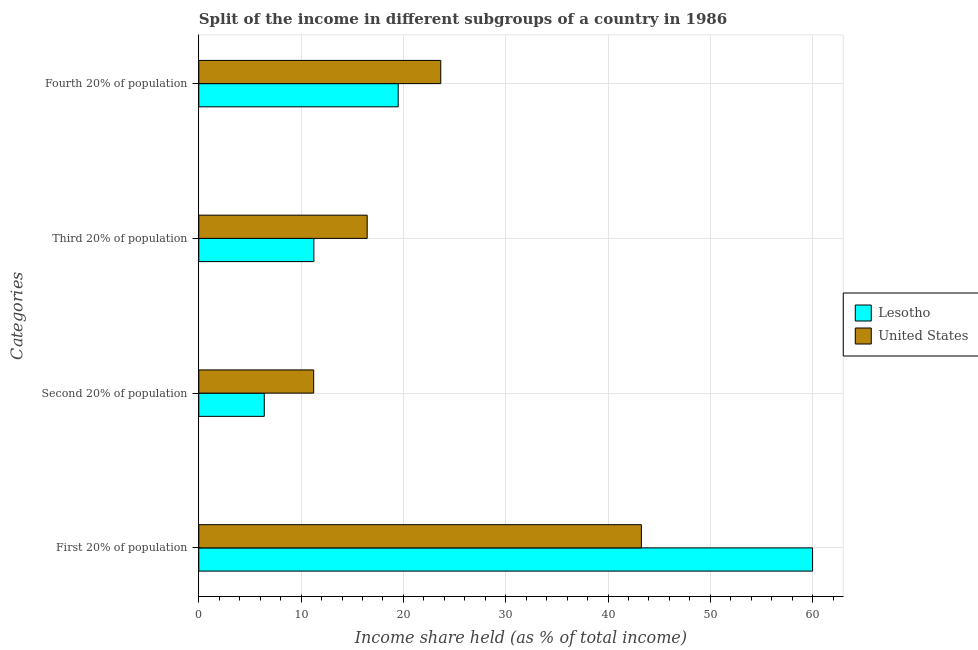How many different coloured bars are there?
Ensure brevity in your answer.  2. Are the number of bars per tick equal to the number of legend labels?
Ensure brevity in your answer.  Yes. Are the number of bars on each tick of the Y-axis equal?
Your response must be concise. Yes. How many bars are there on the 2nd tick from the bottom?
Your answer should be very brief. 2. What is the label of the 3rd group of bars from the top?
Make the answer very short. Second 20% of population. What is the share of the income held by first 20% of the population in Lesotho?
Keep it short and to the point. 59.99. Across all countries, what is the maximum share of the income held by fourth 20% of the population?
Provide a succinct answer. 23.65. Across all countries, what is the minimum share of the income held by first 20% of the population?
Provide a succinct answer. 43.26. In which country was the share of the income held by second 20% of the population maximum?
Give a very brief answer. United States. In which country was the share of the income held by second 20% of the population minimum?
Your response must be concise. Lesotho. What is the total share of the income held by second 20% of the population in the graph?
Offer a terse response. 17.63. What is the difference between the share of the income held by first 20% of the population in United States and that in Lesotho?
Keep it short and to the point. -16.73. What is the difference between the share of the income held by fourth 20% of the population in United States and the share of the income held by first 20% of the population in Lesotho?
Keep it short and to the point. -36.34. What is the average share of the income held by first 20% of the population per country?
Your answer should be compact. 51.62. What is the difference between the share of the income held by fourth 20% of the population and share of the income held by third 20% of the population in Lesotho?
Provide a short and direct response. 8.24. In how many countries, is the share of the income held by third 20% of the population greater than 2 %?
Offer a very short reply. 2. What is the ratio of the share of the income held by fourth 20% of the population in Lesotho to that in United States?
Your response must be concise. 0.82. Is the share of the income held by second 20% of the population in United States less than that in Lesotho?
Your response must be concise. No. Is the difference between the share of the income held by fourth 20% of the population in Lesotho and United States greater than the difference between the share of the income held by third 20% of the population in Lesotho and United States?
Give a very brief answer. Yes. What is the difference between the highest and the second highest share of the income held by fourth 20% of the population?
Keep it short and to the point. 4.16. What is the difference between the highest and the lowest share of the income held by second 20% of the population?
Ensure brevity in your answer.  4.83. In how many countries, is the share of the income held by second 20% of the population greater than the average share of the income held by second 20% of the population taken over all countries?
Provide a succinct answer. 1. Is it the case that in every country, the sum of the share of the income held by first 20% of the population and share of the income held by third 20% of the population is greater than the sum of share of the income held by fourth 20% of the population and share of the income held by second 20% of the population?
Offer a very short reply. Yes. What does the 1st bar from the top in First 20% of population represents?
Your response must be concise. United States. What does the 1st bar from the bottom in First 20% of population represents?
Make the answer very short. Lesotho. How many bars are there?
Your answer should be very brief. 8. How many countries are there in the graph?
Your answer should be very brief. 2. Are the values on the major ticks of X-axis written in scientific E-notation?
Give a very brief answer. No. Does the graph contain any zero values?
Offer a very short reply. No. Does the graph contain grids?
Provide a short and direct response. Yes. How many legend labels are there?
Your response must be concise. 2. What is the title of the graph?
Offer a very short reply. Split of the income in different subgroups of a country in 1986. Does "South Sudan" appear as one of the legend labels in the graph?
Your answer should be very brief. No. What is the label or title of the X-axis?
Ensure brevity in your answer.  Income share held (as % of total income). What is the label or title of the Y-axis?
Your response must be concise. Categories. What is the Income share held (as % of total income) in Lesotho in First 20% of population?
Provide a short and direct response. 59.99. What is the Income share held (as % of total income) of United States in First 20% of population?
Make the answer very short. 43.26. What is the Income share held (as % of total income) of Lesotho in Second 20% of population?
Your response must be concise. 6.4. What is the Income share held (as % of total income) in United States in Second 20% of population?
Provide a succinct answer. 11.23. What is the Income share held (as % of total income) of Lesotho in Third 20% of population?
Offer a very short reply. 11.25. What is the Income share held (as % of total income) of United States in Third 20% of population?
Your answer should be compact. 16.46. What is the Income share held (as % of total income) of Lesotho in Fourth 20% of population?
Provide a succinct answer. 19.49. What is the Income share held (as % of total income) of United States in Fourth 20% of population?
Your response must be concise. 23.65. Across all Categories, what is the maximum Income share held (as % of total income) of Lesotho?
Provide a succinct answer. 59.99. Across all Categories, what is the maximum Income share held (as % of total income) of United States?
Your answer should be very brief. 43.26. Across all Categories, what is the minimum Income share held (as % of total income) in United States?
Provide a short and direct response. 11.23. What is the total Income share held (as % of total income) in Lesotho in the graph?
Make the answer very short. 97.13. What is the total Income share held (as % of total income) in United States in the graph?
Give a very brief answer. 94.6. What is the difference between the Income share held (as % of total income) in Lesotho in First 20% of population and that in Second 20% of population?
Your response must be concise. 53.59. What is the difference between the Income share held (as % of total income) in United States in First 20% of population and that in Second 20% of population?
Offer a terse response. 32.03. What is the difference between the Income share held (as % of total income) in Lesotho in First 20% of population and that in Third 20% of population?
Make the answer very short. 48.74. What is the difference between the Income share held (as % of total income) in United States in First 20% of population and that in Third 20% of population?
Make the answer very short. 26.8. What is the difference between the Income share held (as % of total income) in Lesotho in First 20% of population and that in Fourth 20% of population?
Provide a succinct answer. 40.5. What is the difference between the Income share held (as % of total income) in United States in First 20% of population and that in Fourth 20% of population?
Your answer should be very brief. 19.61. What is the difference between the Income share held (as % of total income) of Lesotho in Second 20% of population and that in Third 20% of population?
Provide a short and direct response. -4.85. What is the difference between the Income share held (as % of total income) of United States in Second 20% of population and that in Third 20% of population?
Your response must be concise. -5.23. What is the difference between the Income share held (as % of total income) of Lesotho in Second 20% of population and that in Fourth 20% of population?
Your response must be concise. -13.09. What is the difference between the Income share held (as % of total income) of United States in Second 20% of population and that in Fourth 20% of population?
Provide a short and direct response. -12.42. What is the difference between the Income share held (as % of total income) in Lesotho in Third 20% of population and that in Fourth 20% of population?
Ensure brevity in your answer.  -8.24. What is the difference between the Income share held (as % of total income) in United States in Third 20% of population and that in Fourth 20% of population?
Offer a terse response. -7.19. What is the difference between the Income share held (as % of total income) in Lesotho in First 20% of population and the Income share held (as % of total income) in United States in Second 20% of population?
Provide a succinct answer. 48.76. What is the difference between the Income share held (as % of total income) of Lesotho in First 20% of population and the Income share held (as % of total income) of United States in Third 20% of population?
Offer a very short reply. 43.53. What is the difference between the Income share held (as % of total income) in Lesotho in First 20% of population and the Income share held (as % of total income) in United States in Fourth 20% of population?
Your response must be concise. 36.34. What is the difference between the Income share held (as % of total income) in Lesotho in Second 20% of population and the Income share held (as % of total income) in United States in Third 20% of population?
Your response must be concise. -10.06. What is the difference between the Income share held (as % of total income) in Lesotho in Second 20% of population and the Income share held (as % of total income) in United States in Fourth 20% of population?
Make the answer very short. -17.25. What is the difference between the Income share held (as % of total income) in Lesotho in Third 20% of population and the Income share held (as % of total income) in United States in Fourth 20% of population?
Give a very brief answer. -12.4. What is the average Income share held (as % of total income) in Lesotho per Categories?
Make the answer very short. 24.28. What is the average Income share held (as % of total income) of United States per Categories?
Keep it short and to the point. 23.65. What is the difference between the Income share held (as % of total income) of Lesotho and Income share held (as % of total income) of United States in First 20% of population?
Your answer should be compact. 16.73. What is the difference between the Income share held (as % of total income) in Lesotho and Income share held (as % of total income) in United States in Second 20% of population?
Your answer should be very brief. -4.83. What is the difference between the Income share held (as % of total income) of Lesotho and Income share held (as % of total income) of United States in Third 20% of population?
Offer a terse response. -5.21. What is the difference between the Income share held (as % of total income) in Lesotho and Income share held (as % of total income) in United States in Fourth 20% of population?
Give a very brief answer. -4.16. What is the ratio of the Income share held (as % of total income) in Lesotho in First 20% of population to that in Second 20% of population?
Provide a succinct answer. 9.37. What is the ratio of the Income share held (as % of total income) in United States in First 20% of population to that in Second 20% of population?
Provide a short and direct response. 3.85. What is the ratio of the Income share held (as % of total income) of Lesotho in First 20% of population to that in Third 20% of population?
Make the answer very short. 5.33. What is the ratio of the Income share held (as % of total income) of United States in First 20% of population to that in Third 20% of population?
Your answer should be compact. 2.63. What is the ratio of the Income share held (as % of total income) of Lesotho in First 20% of population to that in Fourth 20% of population?
Keep it short and to the point. 3.08. What is the ratio of the Income share held (as % of total income) in United States in First 20% of population to that in Fourth 20% of population?
Your response must be concise. 1.83. What is the ratio of the Income share held (as % of total income) of Lesotho in Second 20% of population to that in Third 20% of population?
Give a very brief answer. 0.57. What is the ratio of the Income share held (as % of total income) in United States in Second 20% of population to that in Third 20% of population?
Your response must be concise. 0.68. What is the ratio of the Income share held (as % of total income) of Lesotho in Second 20% of population to that in Fourth 20% of population?
Make the answer very short. 0.33. What is the ratio of the Income share held (as % of total income) in United States in Second 20% of population to that in Fourth 20% of population?
Your response must be concise. 0.47. What is the ratio of the Income share held (as % of total income) of Lesotho in Third 20% of population to that in Fourth 20% of population?
Your answer should be compact. 0.58. What is the ratio of the Income share held (as % of total income) in United States in Third 20% of population to that in Fourth 20% of population?
Provide a succinct answer. 0.7. What is the difference between the highest and the second highest Income share held (as % of total income) of Lesotho?
Give a very brief answer. 40.5. What is the difference between the highest and the second highest Income share held (as % of total income) in United States?
Offer a terse response. 19.61. What is the difference between the highest and the lowest Income share held (as % of total income) in Lesotho?
Offer a very short reply. 53.59. What is the difference between the highest and the lowest Income share held (as % of total income) in United States?
Ensure brevity in your answer.  32.03. 